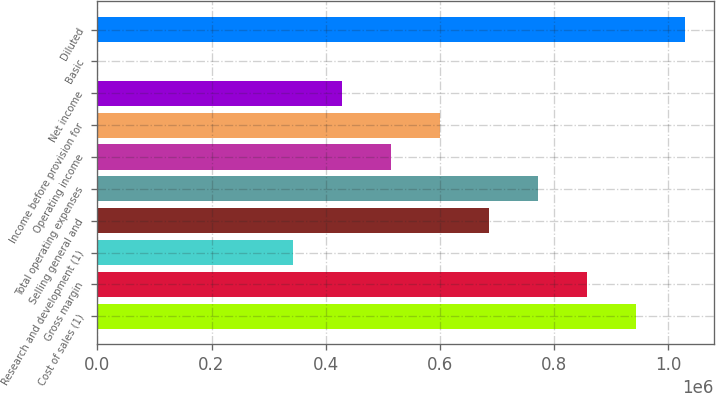Convert chart to OTSL. <chart><loc_0><loc_0><loc_500><loc_500><bar_chart><fcel>Cost of sales (1)<fcel>Gross margin<fcel>Research and development (1)<fcel>Selling general and<fcel>Total operating expenses<fcel>Operating income<fcel>Income before provision for<fcel>Net income<fcel>Basic<fcel>Diluted<nl><fcel>942566<fcel>856878<fcel>342752<fcel>685503<fcel>771190<fcel>514127<fcel>599815<fcel>428440<fcel>1.64<fcel>1.02825e+06<nl></chart> 